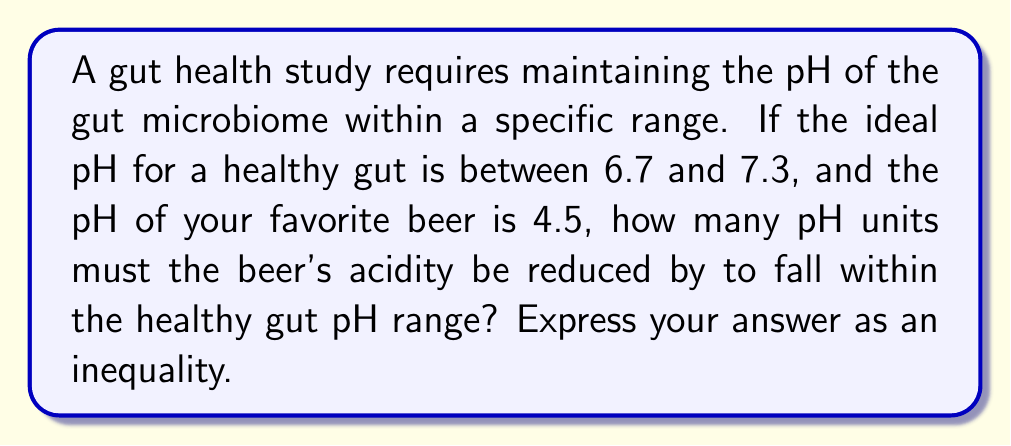Provide a solution to this math problem. Let's approach this step-by-step:

1) The ideal pH range for a healthy gut is given as 6.7 to 7.3. We can express this as an inequality:

   $$6.7 \leq \text{pH} \leq 7.3$$

2) The pH of the beer is 4.5, which is more acidic than the lower bound of the healthy range.

3) To find how many pH units the beer's acidity must be reduced, we need to calculate the difference between the beer's pH and the lower bound of the healthy range:

   $$\text{Minimum pH increase} = 6.7 - 4.5 = 2.2$$

4) However, any pH increase between 2.2 and 2.8 would bring the beer's pH into the healthy range:

   $$6.7 \leq 4.5 + x \leq 7.3$$

   Where $x$ is the number of pH units the beer's acidity must be reduced by.

5) Subtracting 4.5 from each part of the inequality:

   $$2.2 \leq x \leq 2.8$$

This inequality represents the range of pH units by which the beer's acidity must be reduced to fall within the healthy gut pH range.
Answer: $$2.2 \leq x \leq 2.8$$ 